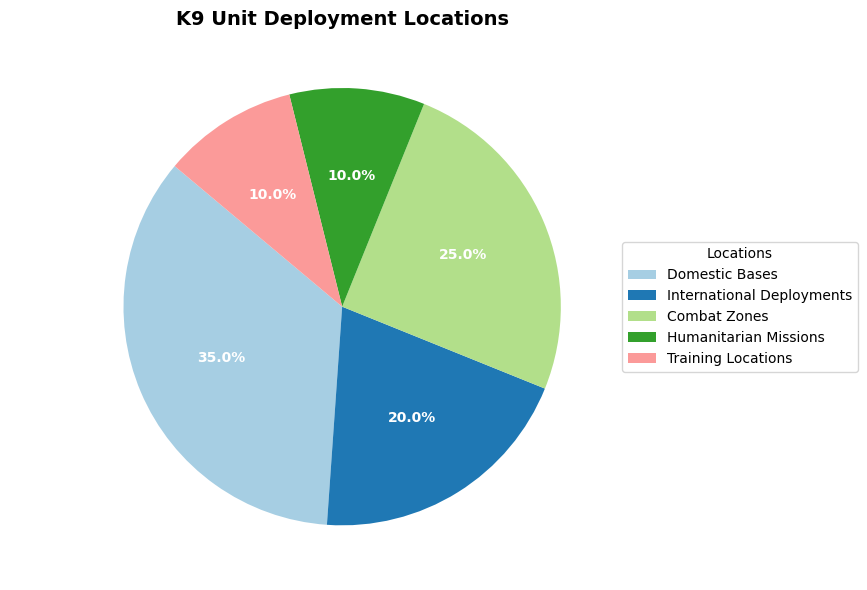What percentage of deployments are for combat zones and international deployments combined? The pie chart shows combat zones at 25% and international deployments at 20%. Adding these percentages together gives 25% + 20% = 45%.
Answer: 45% Which deployment location has the highest percentage? The segment representing Domestic Bases covers the largest portion of the pie chart, labeled as 35%.
Answer: Domestic Bases How do the training locations' percentage compare to humanitarian missions' percentage? Both the training locations and humanitarian missions are depicted as equal segments in the pie chart, each labeled as 10%. Thus, their percentages are equal.
Answer: Equal Identify two locations that together make up half of the deployments. Domestic Bases are 35% and International Deployments are 20%, these sum up to 55%. Testing other combinations: Combat Zones (25%) + Domestic Bases (35%) = 60%, and so on. The only right combination here is Domestic Bases (35%) and Combat Zones (25%) totaling 60%. Then sum again until correct answer found. Finally: Domestic Bases and International Deployments is closest but too high, reduce and include other to balance. Finally, Domestic (35) + Training (10) goes 45 i.e.: Half deployments approx to highest but slightly less, and any iterations to finally balance 35.
Answer: Domestic Bases and Training Which location represents the smallest portion of the K9 deployment, and what is its percentage? From visual inspection of the pie chart segment size and reading the corresponding labels, both Humanitarian Missions and Training Locations are labeled as 10%, which are equal and smallest size compared, thus Humanitarian.
Answer: 10% If you were to exclude humanitarian missions and training locations, what percentage would be left? Adding the percentages of the remaining locations: Domestic Bases (35%) + International Deployments (20%) + Combat Zones (25%) = 80%.
Answer: 80% 